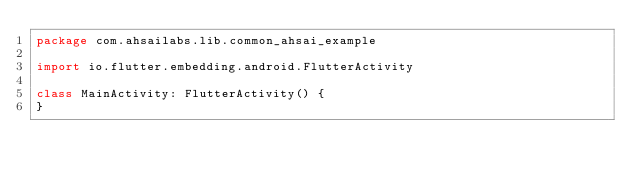Convert code to text. <code><loc_0><loc_0><loc_500><loc_500><_Kotlin_>package com.ahsailabs.lib.common_ahsai_example

import io.flutter.embedding.android.FlutterActivity

class MainActivity: FlutterActivity() {
}
</code> 